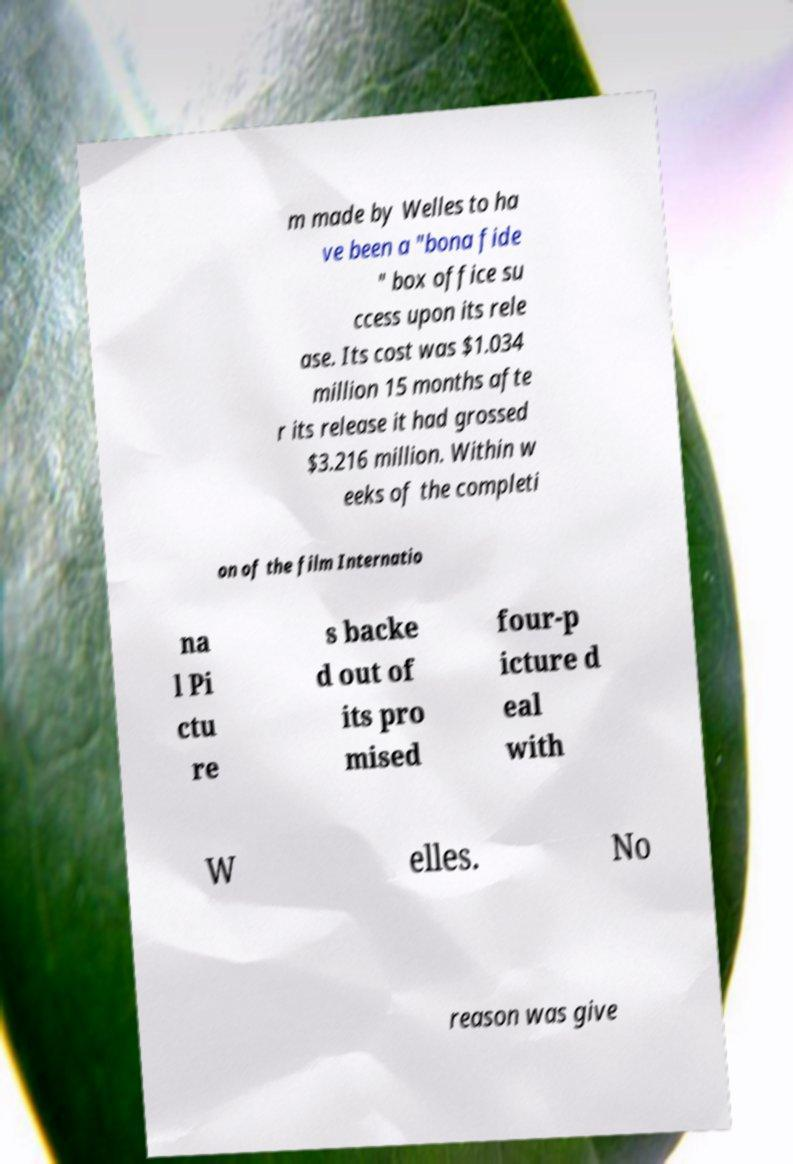Can you accurately transcribe the text from the provided image for me? m made by Welles to ha ve been a "bona fide " box office su ccess upon its rele ase. Its cost was $1.034 million 15 months afte r its release it had grossed $3.216 million. Within w eeks of the completi on of the film Internatio na l Pi ctu re s backe d out of its pro mised four-p icture d eal with W elles. No reason was give 